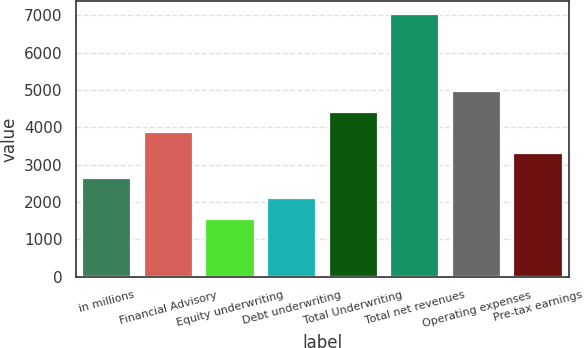Convert chart. <chart><loc_0><loc_0><loc_500><loc_500><bar_chart><fcel>in millions<fcel>Financial Advisory<fcel>Equity underwriting<fcel>Debt underwriting<fcel>Total Underwriting<fcel>Total net revenues<fcel>Operating expenses<fcel>Pre-tax earnings<nl><fcel>2642.2<fcel>3862.1<fcel>1546<fcel>2094.1<fcel>4410.2<fcel>7027<fcel>4958.3<fcel>3314<nl></chart> 